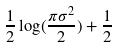<formula> <loc_0><loc_0><loc_500><loc_500>\frac { 1 } { 2 } \log ( \frac { \pi \sigma ^ { 2 } } { 2 } ) + \frac { 1 } { 2 }</formula> 